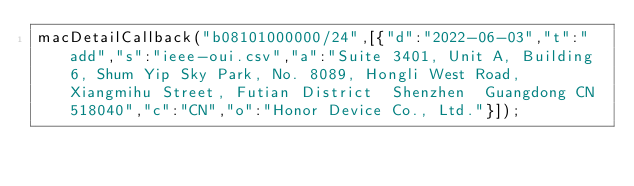Convert code to text. <code><loc_0><loc_0><loc_500><loc_500><_JavaScript_>macDetailCallback("b08101000000/24",[{"d":"2022-06-03","t":"add","s":"ieee-oui.csv","a":"Suite 3401, Unit A, Building 6, Shum Yip Sky Park, No. 8089, Hongli West Road, Xiangmihu Street, Futian District  Shenzhen  Guangdong CN 518040","c":"CN","o":"Honor Device Co., Ltd."}]);
</code> 